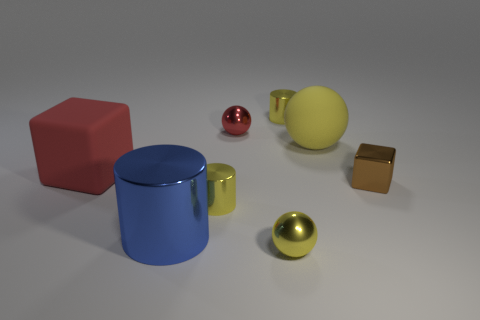Subtract all big blue cylinders. How many cylinders are left? 2 Add 1 big spheres. How many objects exist? 9 Subtract 3 balls. How many balls are left? 0 Subtract all yellow spheres. How many spheres are left? 1 Subtract all blocks. How many objects are left? 6 Subtract all brown cylinders. How many green cubes are left? 0 Add 1 big blue things. How many big blue things are left? 2 Add 2 metallic cylinders. How many metallic cylinders exist? 5 Subtract 0 blue cubes. How many objects are left? 8 Subtract all red spheres. Subtract all yellow cylinders. How many spheres are left? 2 